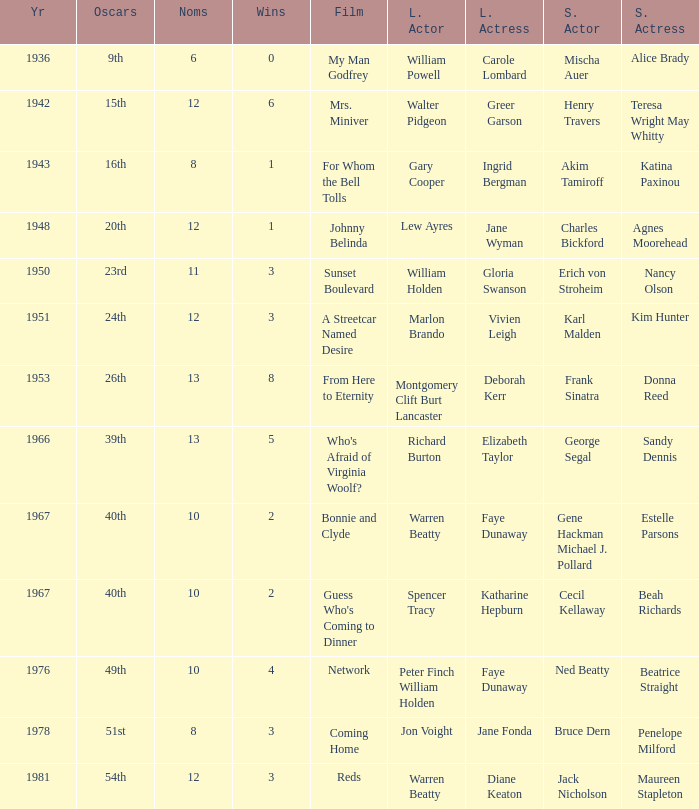Who was the leading actress in a film with Warren Beatty as the leading actor and also at the 40th Oscars? Faye Dunaway. 